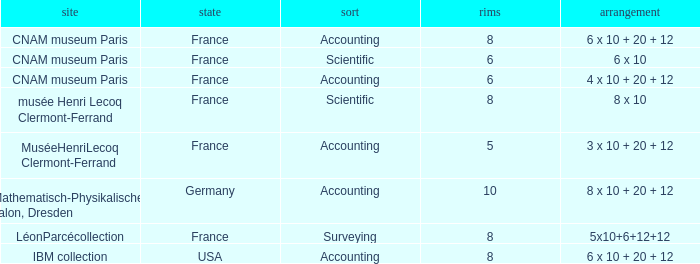What location has surveying as the type? LéonParcécollection. 